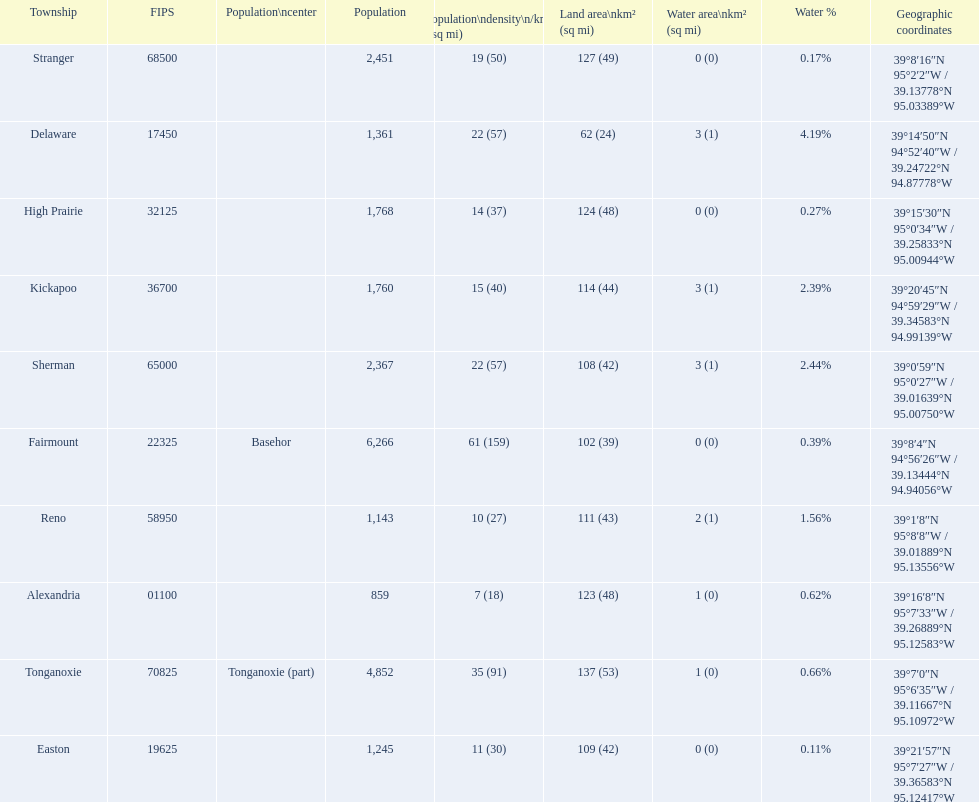Was delaware's land area above or below 45 square miles? Above. 